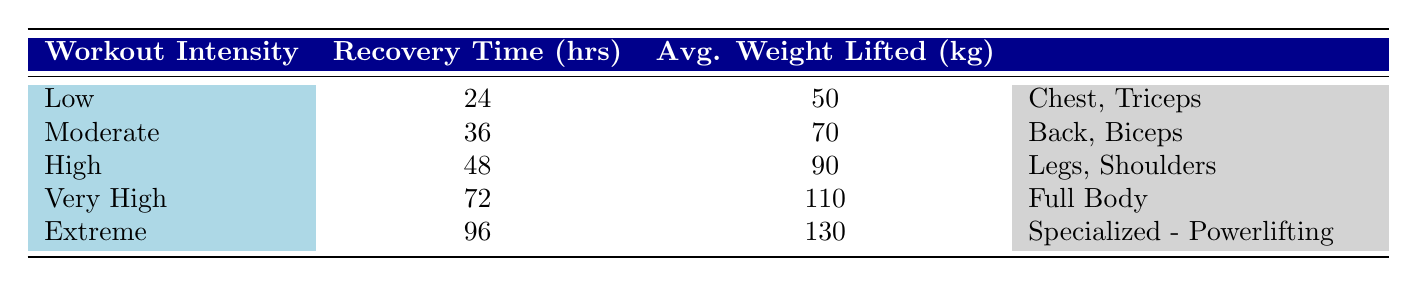What is the recovery time for a low-intensity workout? According to the table, the recovery time for a low-intensity workout is directly stated as 24 hours.
Answer: 24 hours How many hours of recovery do you need after an extreme intensity workout? The table shows that the recovery time after an extreme intensity workout is 96 hours.
Answer: 96 hours Which workout intensity has the highest average weight lifted? By examining the table, the extreme workout intensity is associated with the highest average weight lifted at 130 kg.
Answer: Extreme Is the muscle group targeted during a high-intensity workout the same as for a moderate intensity workout? The table indicates that a high-intensity workout targets "Legs, Shoulders," while a moderate intensity workout targets "Back, Biceps." Since these muscle groups are different, the answer is no.
Answer: No How does recovery time change from low to extreme workout intensity? The recovery time increases from 24 hours (low) to 96 hours (extreme). To find the difference, we subtract: 96 - 24 = 72 hours, indicating a significant increase in recovery time as intensity rises.
Answer: 72 hours What is the average recovery time across all recorded workout intensities? To calculate the average recovery time, we sum the recovery times (24 + 36 + 48 + 72 + 96 = 276) and divide by the number of intensity levels (5). This gives us 276/5 = 55.2 hours.
Answer: 55.2 hours Are the muscle groups targeted for low and very high intensities different? The low intensity targets "Chest, Triceps," while the very high intensity targets "Full Body." Since the targeted muscle groups are different, the answer is yes.
Answer: Yes Which intensity level corresponds to an average weight lifted of 90 kg? Looking at the table, 90 kg is listed under the high intensity workout category.
Answer: High If you were to categorize the recovery time in intervals, what range does moderate intensity fall into? Moderate intensity has a recovery time of 36 hours, which is between 24 (low) and 48 (high) hours. Thus, it falls in the range 24-48 hours.
Answer: 24-48 hours 